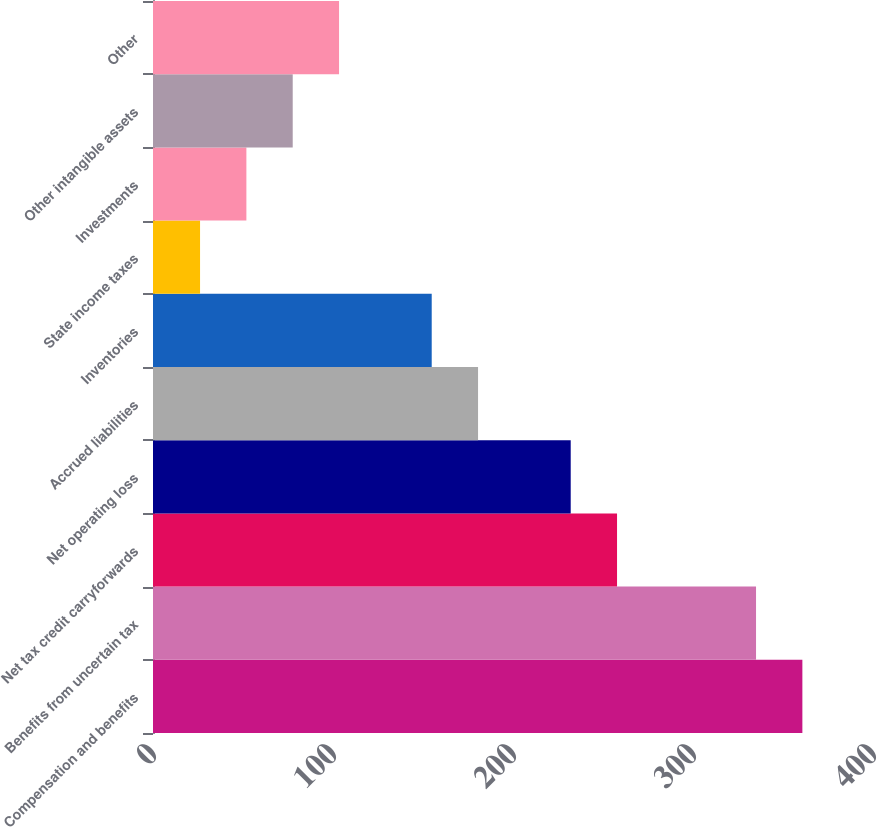Convert chart to OTSL. <chart><loc_0><loc_0><loc_500><loc_500><bar_chart><fcel>Compensation and benefits<fcel>Benefits from uncertain tax<fcel>Net tax credit carryforwards<fcel>Net operating loss<fcel>Accrued liabilities<fcel>Inventories<fcel>State income taxes<fcel>Investments<fcel>Other intangible assets<fcel>Other<nl><fcel>360.76<fcel>335.02<fcel>257.8<fcel>232.06<fcel>180.58<fcel>154.84<fcel>26.14<fcel>51.88<fcel>77.62<fcel>103.36<nl></chart> 